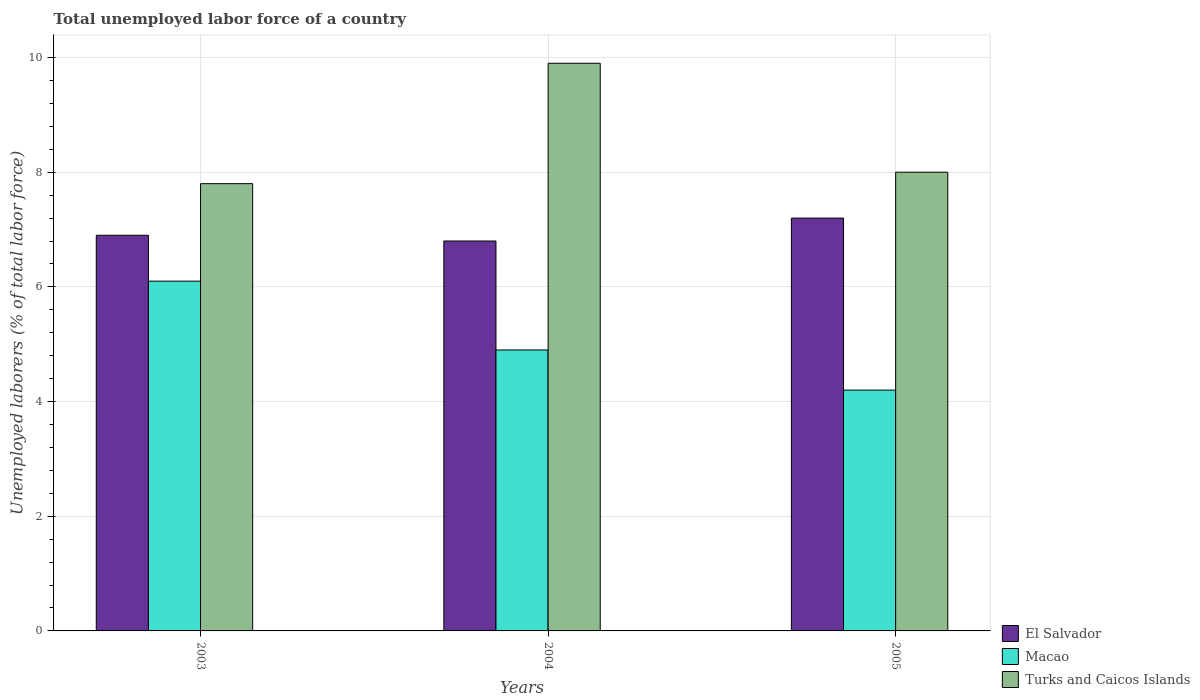How many groups of bars are there?
Offer a very short reply. 3. Are the number of bars on each tick of the X-axis equal?
Make the answer very short. Yes. How many bars are there on the 3rd tick from the left?
Give a very brief answer. 3. What is the label of the 2nd group of bars from the left?
Your answer should be very brief. 2004. In how many cases, is the number of bars for a given year not equal to the number of legend labels?
Offer a very short reply. 0. What is the total unemployed labor force in El Salvador in 2003?
Ensure brevity in your answer.  6.9. Across all years, what is the maximum total unemployed labor force in El Salvador?
Ensure brevity in your answer.  7.2. Across all years, what is the minimum total unemployed labor force in Turks and Caicos Islands?
Ensure brevity in your answer.  7.8. What is the total total unemployed labor force in El Salvador in the graph?
Your answer should be very brief. 20.9. What is the difference between the total unemployed labor force in Turks and Caicos Islands in 2003 and that in 2004?
Make the answer very short. -2.1. What is the difference between the total unemployed labor force in El Salvador in 2005 and the total unemployed labor force in Turks and Caicos Islands in 2004?
Offer a terse response. -2.7. What is the average total unemployed labor force in El Salvador per year?
Keep it short and to the point. 6.97. In the year 2004, what is the difference between the total unemployed labor force in Macao and total unemployed labor force in Turks and Caicos Islands?
Offer a very short reply. -5. In how many years, is the total unemployed labor force in Turks and Caicos Islands greater than 5.6 %?
Make the answer very short. 3. What is the ratio of the total unemployed labor force in El Salvador in 2003 to that in 2005?
Give a very brief answer. 0.96. Is the total unemployed labor force in Macao in 2003 less than that in 2005?
Provide a succinct answer. No. Is the difference between the total unemployed labor force in Macao in 2003 and 2004 greater than the difference between the total unemployed labor force in Turks and Caicos Islands in 2003 and 2004?
Your answer should be compact. Yes. What is the difference between the highest and the second highest total unemployed labor force in Macao?
Your answer should be compact. 1.2. What is the difference between the highest and the lowest total unemployed labor force in El Salvador?
Provide a short and direct response. 0.4. In how many years, is the total unemployed labor force in Turks and Caicos Islands greater than the average total unemployed labor force in Turks and Caicos Islands taken over all years?
Provide a short and direct response. 1. What does the 1st bar from the left in 2003 represents?
Your response must be concise. El Salvador. What does the 1st bar from the right in 2003 represents?
Your answer should be very brief. Turks and Caicos Islands. How many bars are there?
Keep it short and to the point. 9. Are all the bars in the graph horizontal?
Keep it short and to the point. No. How many years are there in the graph?
Your response must be concise. 3. Does the graph contain grids?
Ensure brevity in your answer.  Yes. Where does the legend appear in the graph?
Provide a short and direct response. Bottom right. How are the legend labels stacked?
Make the answer very short. Vertical. What is the title of the graph?
Keep it short and to the point. Total unemployed labor force of a country. What is the label or title of the X-axis?
Your answer should be very brief. Years. What is the label or title of the Y-axis?
Keep it short and to the point. Unemployed laborers (% of total labor force). What is the Unemployed laborers (% of total labor force) of El Salvador in 2003?
Give a very brief answer. 6.9. What is the Unemployed laborers (% of total labor force) in Macao in 2003?
Ensure brevity in your answer.  6.1. What is the Unemployed laborers (% of total labor force) of Turks and Caicos Islands in 2003?
Ensure brevity in your answer.  7.8. What is the Unemployed laborers (% of total labor force) in El Salvador in 2004?
Ensure brevity in your answer.  6.8. What is the Unemployed laborers (% of total labor force) of Macao in 2004?
Give a very brief answer. 4.9. What is the Unemployed laborers (% of total labor force) in Turks and Caicos Islands in 2004?
Offer a very short reply. 9.9. What is the Unemployed laborers (% of total labor force) of El Salvador in 2005?
Offer a very short reply. 7.2. What is the Unemployed laborers (% of total labor force) in Macao in 2005?
Offer a very short reply. 4.2. Across all years, what is the maximum Unemployed laborers (% of total labor force) of El Salvador?
Your response must be concise. 7.2. Across all years, what is the maximum Unemployed laborers (% of total labor force) in Macao?
Your response must be concise. 6.1. Across all years, what is the maximum Unemployed laborers (% of total labor force) in Turks and Caicos Islands?
Give a very brief answer. 9.9. Across all years, what is the minimum Unemployed laborers (% of total labor force) in El Salvador?
Provide a short and direct response. 6.8. Across all years, what is the minimum Unemployed laborers (% of total labor force) of Macao?
Your response must be concise. 4.2. Across all years, what is the minimum Unemployed laborers (% of total labor force) of Turks and Caicos Islands?
Offer a terse response. 7.8. What is the total Unemployed laborers (% of total labor force) in El Salvador in the graph?
Offer a very short reply. 20.9. What is the total Unemployed laborers (% of total labor force) of Macao in the graph?
Ensure brevity in your answer.  15.2. What is the total Unemployed laborers (% of total labor force) of Turks and Caicos Islands in the graph?
Give a very brief answer. 25.7. What is the difference between the Unemployed laborers (% of total labor force) in El Salvador in 2003 and that in 2004?
Provide a short and direct response. 0.1. What is the difference between the Unemployed laborers (% of total labor force) in Turks and Caicos Islands in 2003 and that in 2004?
Provide a succinct answer. -2.1. What is the difference between the Unemployed laborers (% of total labor force) of Macao in 2003 and that in 2005?
Make the answer very short. 1.9. What is the difference between the Unemployed laborers (% of total labor force) in El Salvador in 2003 and the Unemployed laborers (% of total labor force) in Turks and Caicos Islands in 2004?
Provide a succinct answer. -3. What is the difference between the Unemployed laborers (% of total labor force) of Macao in 2003 and the Unemployed laborers (% of total labor force) of Turks and Caicos Islands in 2004?
Give a very brief answer. -3.8. What is the difference between the Unemployed laborers (% of total labor force) in El Salvador in 2003 and the Unemployed laborers (% of total labor force) in Turks and Caicos Islands in 2005?
Your answer should be very brief. -1.1. What is the difference between the Unemployed laborers (% of total labor force) in El Salvador in 2004 and the Unemployed laborers (% of total labor force) in Macao in 2005?
Your answer should be very brief. 2.6. What is the difference between the Unemployed laborers (% of total labor force) in El Salvador in 2004 and the Unemployed laborers (% of total labor force) in Turks and Caicos Islands in 2005?
Provide a succinct answer. -1.2. What is the difference between the Unemployed laborers (% of total labor force) in Macao in 2004 and the Unemployed laborers (% of total labor force) in Turks and Caicos Islands in 2005?
Provide a succinct answer. -3.1. What is the average Unemployed laborers (% of total labor force) of El Salvador per year?
Provide a short and direct response. 6.97. What is the average Unemployed laborers (% of total labor force) of Macao per year?
Make the answer very short. 5.07. What is the average Unemployed laborers (% of total labor force) in Turks and Caicos Islands per year?
Your answer should be compact. 8.57. In the year 2003, what is the difference between the Unemployed laborers (% of total labor force) of El Salvador and Unemployed laborers (% of total labor force) of Macao?
Offer a very short reply. 0.8. In the year 2003, what is the difference between the Unemployed laborers (% of total labor force) of El Salvador and Unemployed laborers (% of total labor force) of Turks and Caicos Islands?
Ensure brevity in your answer.  -0.9. In the year 2003, what is the difference between the Unemployed laborers (% of total labor force) of Macao and Unemployed laborers (% of total labor force) of Turks and Caicos Islands?
Ensure brevity in your answer.  -1.7. In the year 2004, what is the difference between the Unemployed laborers (% of total labor force) of El Salvador and Unemployed laborers (% of total labor force) of Turks and Caicos Islands?
Offer a very short reply. -3.1. In the year 2005, what is the difference between the Unemployed laborers (% of total labor force) in Macao and Unemployed laborers (% of total labor force) in Turks and Caicos Islands?
Offer a terse response. -3.8. What is the ratio of the Unemployed laborers (% of total labor force) in El Salvador in 2003 to that in 2004?
Provide a short and direct response. 1.01. What is the ratio of the Unemployed laborers (% of total labor force) in Macao in 2003 to that in 2004?
Ensure brevity in your answer.  1.24. What is the ratio of the Unemployed laborers (% of total labor force) in Turks and Caicos Islands in 2003 to that in 2004?
Your answer should be compact. 0.79. What is the ratio of the Unemployed laborers (% of total labor force) of Macao in 2003 to that in 2005?
Your answer should be very brief. 1.45. What is the ratio of the Unemployed laborers (% of total labor force) of Turks and Caicos Islands in 2004 to that in 2005?
Your answer should be very brief. 1.24. What is the difference between the highest and the second highest Unemployed laborers (% of total labor force) in El Salvador?
Ensure brevity in your answer.  0.3. What is the difference between the highest and the second highest Unemployed laborers (% of total labor force) of Macao?
Offer a very short reply. 1.2. What is the difference between the highest and the second highest Unemployed laborers (% of total labor force) of Turks and Caicos Islands?
Provide a short and direct response. 1.9. What is the difference between the highest and the lowest Unemployed laborers (% of total labor force) of Macao?
Give a very brief answer. 1.9. 